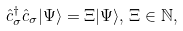<formula> <loc_0><loc_0><loc_500><loc_500>\hat { c } _ { \sigma } ^ { \dagger } \hat { c } _ { \sigma } | \Psi \rangle = \Xi | \Psi \rangle , \, \Xi \in \mathbb { N } ,</formula> 